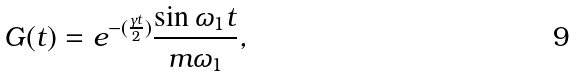<formula> <loc_0><loc_0><loc_500><loc_500>G ( t ) = e ^ { - { ( \frac { \gamma { t } } { 2 } ) } } \frac { \sin \omega _ { 1 } t } { m \omega _ { 1 } } ,</formula> 